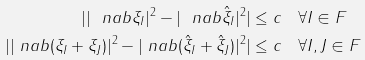<formula> <loc_0><loc_0><loc_500><loc_500>| | \ n a b \xi _ { I } | ^ { 2 } - | \ n a b { \hat { \xi } } _ { I } | ^ { 2 } | & \leq c \quad \forall I \in F \\ | | \ n a b ( \xi _ { I } + \xi _ { J } ) | ^ { 2 } - | \ n a b ( { \hat { \xi } } _ { I } + { \hat { \xi } } _ { J } ) | ^ { 2 } | & \leq c \quad \forall I , J \in F</formula> 